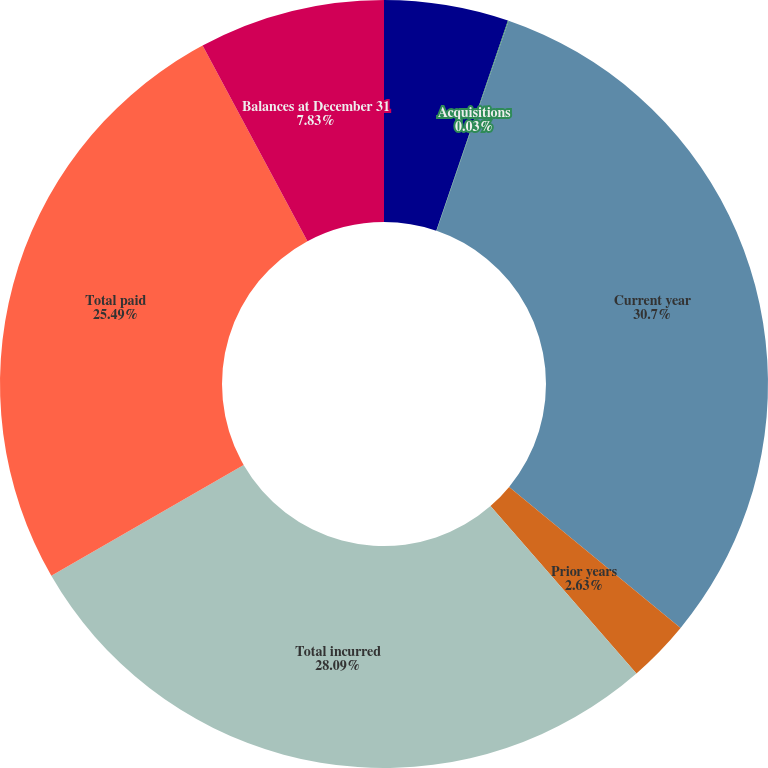Convert chart. <chart><loc_0><loc_0><loc_500><loc_500><pie_chart><fcel>Balances at January 1<fcel>Acquisitions<fcel>Current year<fcel>Prior years<fcel>Total incurred<fcel>Total paid<fcel>Balances at December 31<nl><fcel>5.23%<fcel>0.03%<fcel>30.69%<fcel>2.63%<fcel>28.09%<fcel>25.49%<fcel>7.83%<nl></chart> 